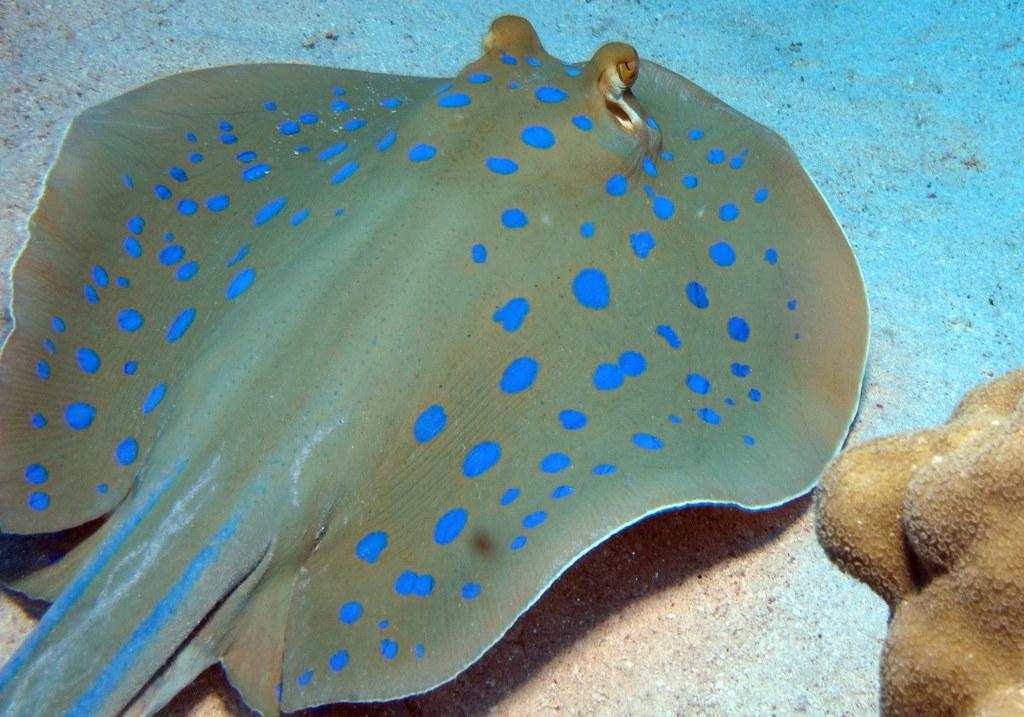What type of marine animal is in the image? There is a stingray in the image. What type of underwater habitat is visible in the image? There is a coral reef in the image. Are the stingray and coral reef in the same environment in the image? Yes, both the stingray and the coral reef are in the water in the image. What time of day is it in the image, as indicated by the position of the sofa? There is no sofa present in the image, and therefore no indication of the time of day. 